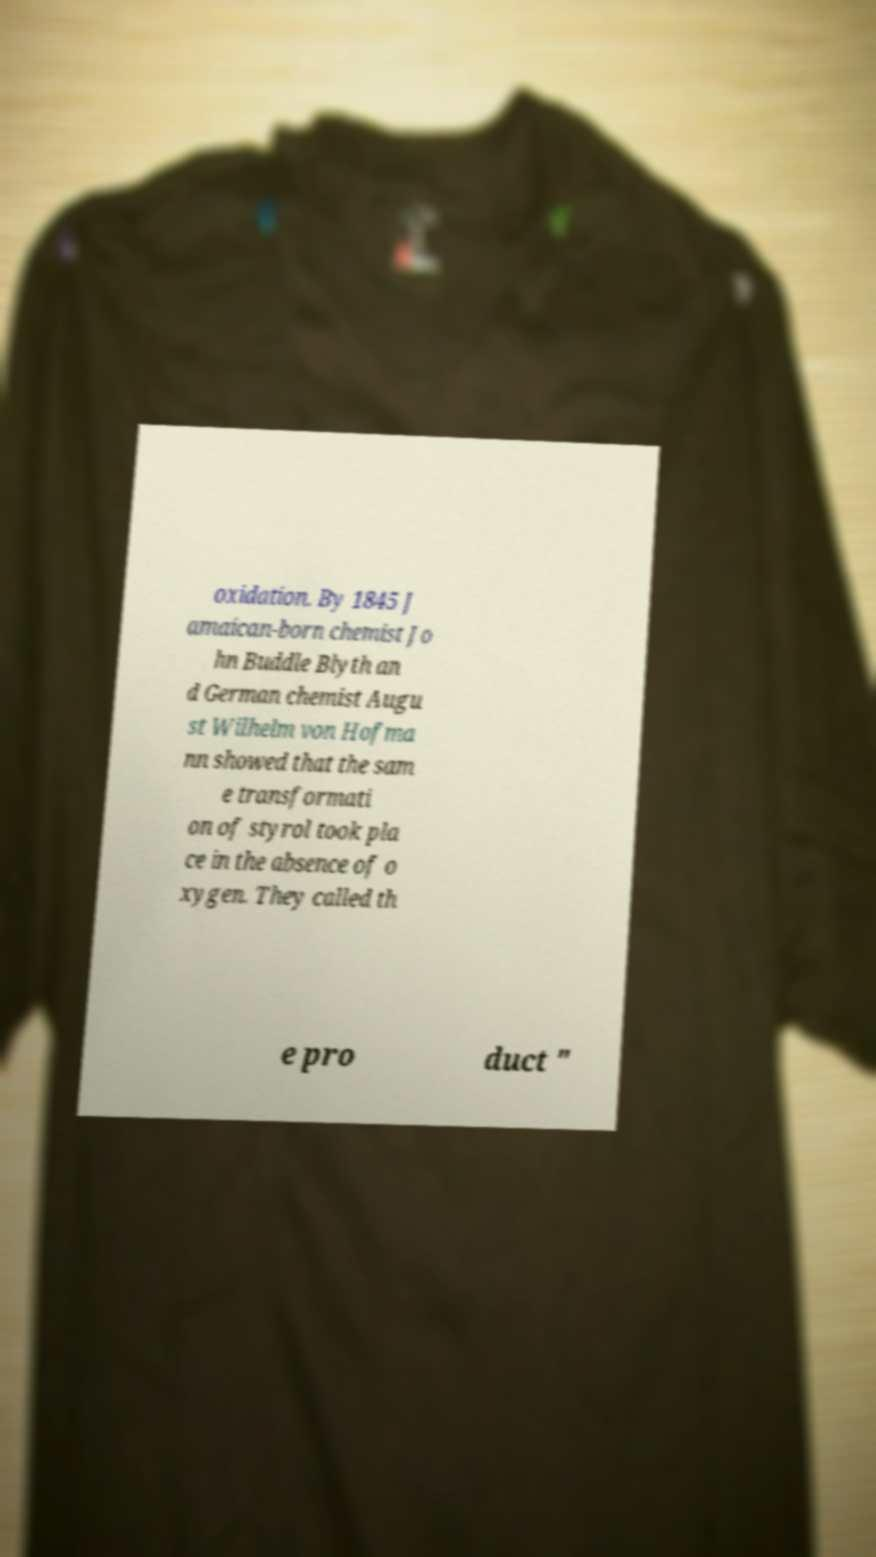Can you read and provide the text displayed in the image?This photo seems to have some interesting text. Can you extract and type it out for me? oxidation. By 1845 J amaican-born chemist Jo hn Buddle Blyth an d German chemist Augu st Wilhelm von Hofma nn showed that the sam e transformati on of styrol took pla ce in the absence of o xygen. They called th e pro duct " 